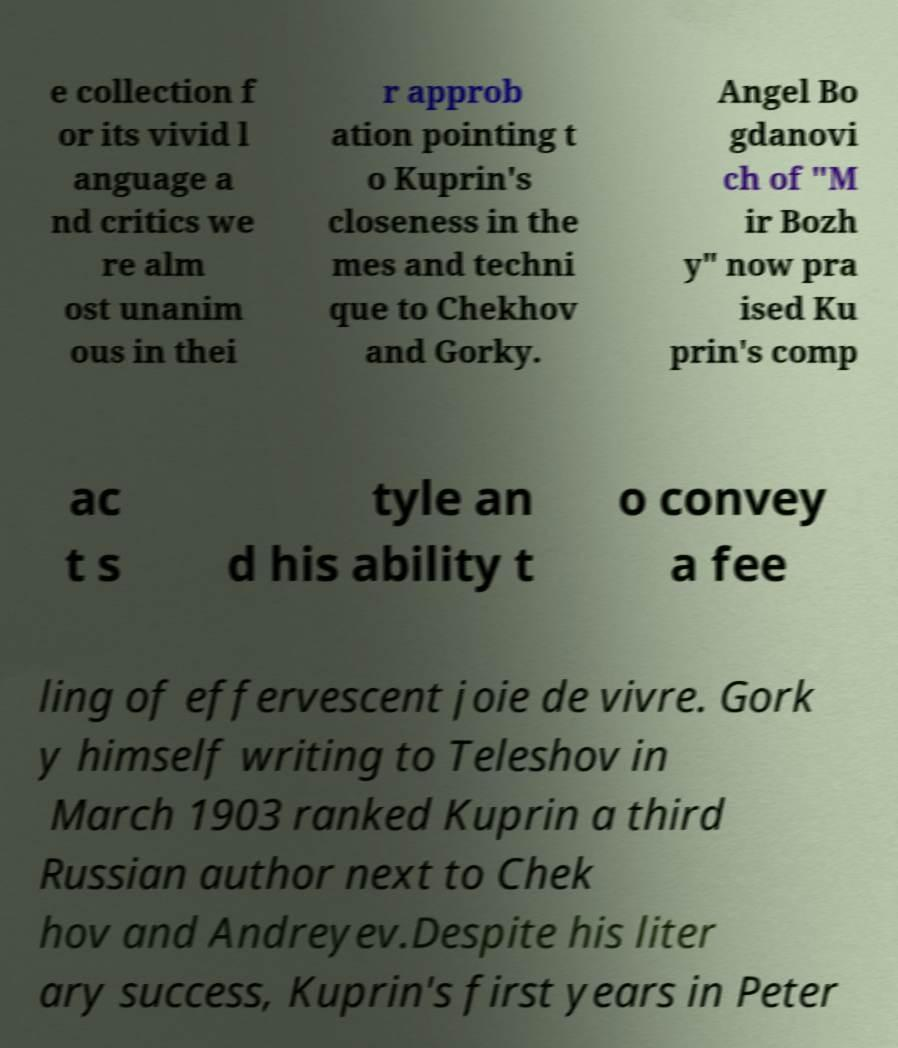Please read and relay the text visible in this image. What does it say? e collection f or its vivid l anguage a nd critics we re alm ost unanim ous in thei r approb ation pointing t o Kuprin's closeness in the mes and techni que to Chekhov and Gorky. Angel Bo gdanovi ch of "M ir Bozh y" now pra ised Ku prin's comp ac t s tyle an d his ability t o convey a fee ling of effervescent joie de vivre. Gork y himself writing to Teleshov in March 1903 ranked Kuprin a third Russian author next to Chek hov and Andreyev.Despite his liter ary success, Kuprin's first years in Peter 